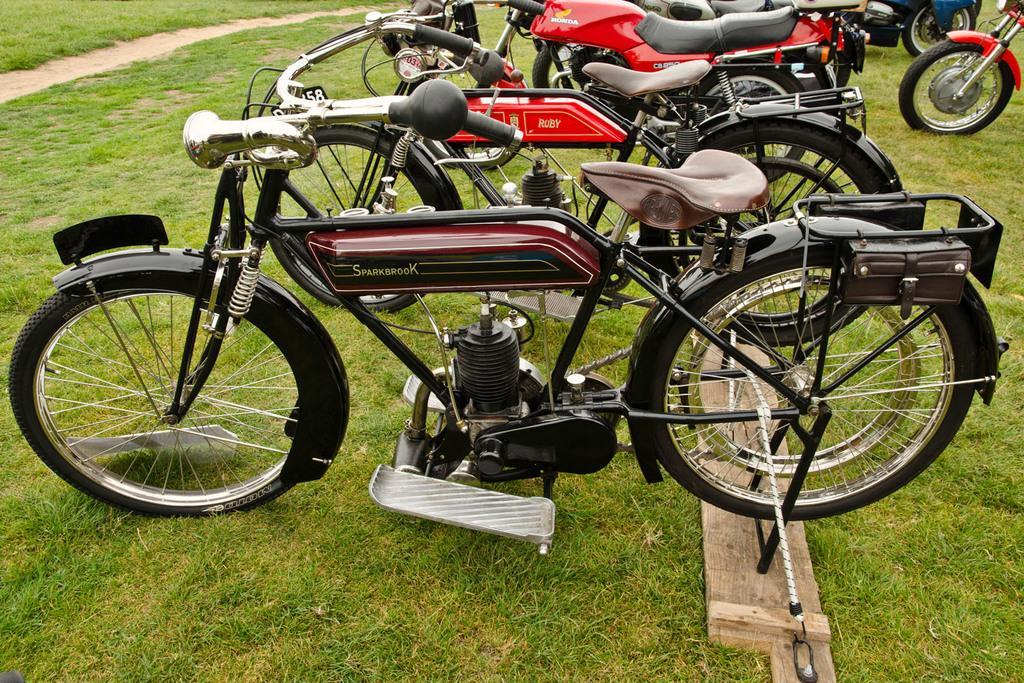Can you describe this image briefly? This image consists of bikes parked on the ground. At the bottom, there is green grass. In the front, the bike is in brown color. In the background, the bikes are in red color. 